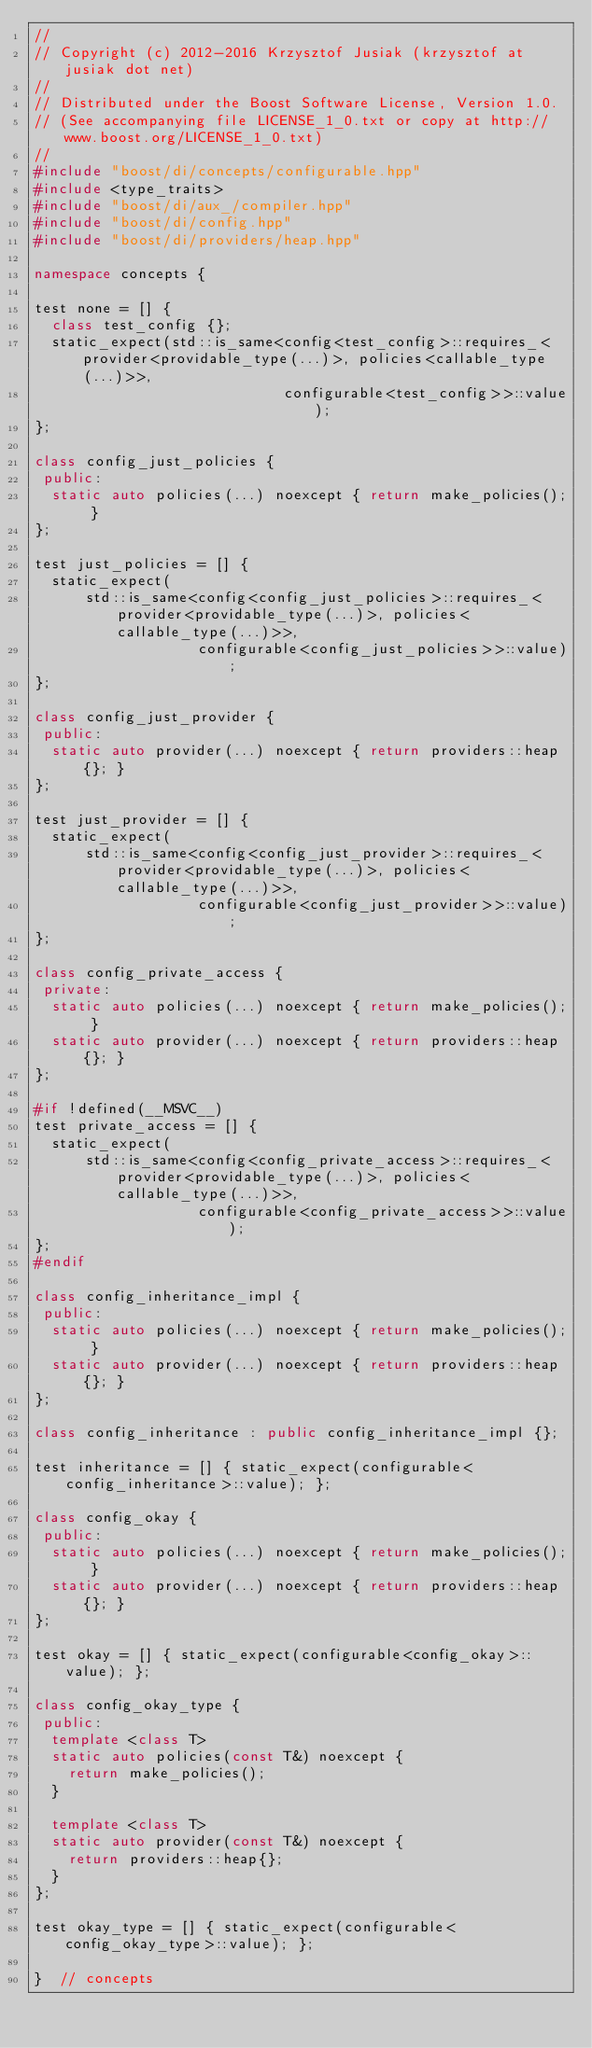Convert code to text. <code><loc_0><loc_0><loc_500><loc_500><_C++_>//
// Copyright (c) 2012-2016 Krzysztof Jusiak (krzysztof at jusiak dot net)
//
// Distributed under the Boost Software License, Version 1.0.
// (See accompanying file LICENSE_1_0.txt or copy at http://www.boost.org/LICENSE_1_0.txt)
//
#include "boost/di/concepts/configurable.hpp"
#include <type_traits>
#include "boost/di/aux_/compiler.hpp"
#include "boost/di/config.hpp"
#include "boost/di/providers/heap.hpp"

namespace concepts {

test none = [] {
  class test_config {};
  static_expect(std::is_same<config<test_config>::requires_<provider<providable_type(...)>, policies<callable_type(...)>>,
                             configurable<test_config>>::value);
};

class config_just_policies {
 public:
  static auto policies(...) noexcept { return make_policies(); }
};

test just_policies = [] {
  static_expect(
      std::is_same<config<config_just_policies>::requires_<provider<providable_type(...)>, policies<callable_type(...)>>,
                   configurable<config_just_policies>>::value);
};

class config_just_provider {
 public:
  static auto provider(...) noexcept { return providers::heap{}; }
};

test just_provider = [] {
  static_expect(
      std::is_same<config<config_just_provider>::requires_<provider<providable_type(...)>, policies<callable_type(...)>>,
                   configurable<config_just_provider>>::value);
};

class config_private_access {
 private:
  static auto policies(...) noexcept { return make_policies(); }
  static auto provider(...) noexcept { return providers::heap{}; }
};

#if !defined(__MSVC__)
test private_access = [] {
  static_expect(
      std::is_same<config<config_private_access>::requires_<provider<providable_type(...)>, policies<callable_type(...)>>,
                   configurable<config_private_access>>::value);
};
#endif

class config_inheritance_impl {
 public:
  static auto policies(...) noexcept { return make_policies(); }
  static auto provider(...) noexcept { return providers::heap{}; }
};

class config_inheritance : public config_inheritance_impl {};

test inheritance = [] { static_expect(configurable<config_inheritance>::value); };

class config_okay {
 public:
  static auto policies(...) noexcept { return make_policies(); }
  static auto provider(...) noexcept { return providers::heap{}; }
};

test okay = [] { static_expect(configurable<config_okay>::value); };

class config_okay_type {
 public:
  template <class T>
  static auto policies(const T&) noexcept {
    return make_policies();
  }

  template <class T>
  static auto provider(const T&) noexcept {
    return providers::heap{};
  }
};

test okay_type = [] { static_expect(configurable<config_okay_type>::value); };

}  // concepts
</code> 